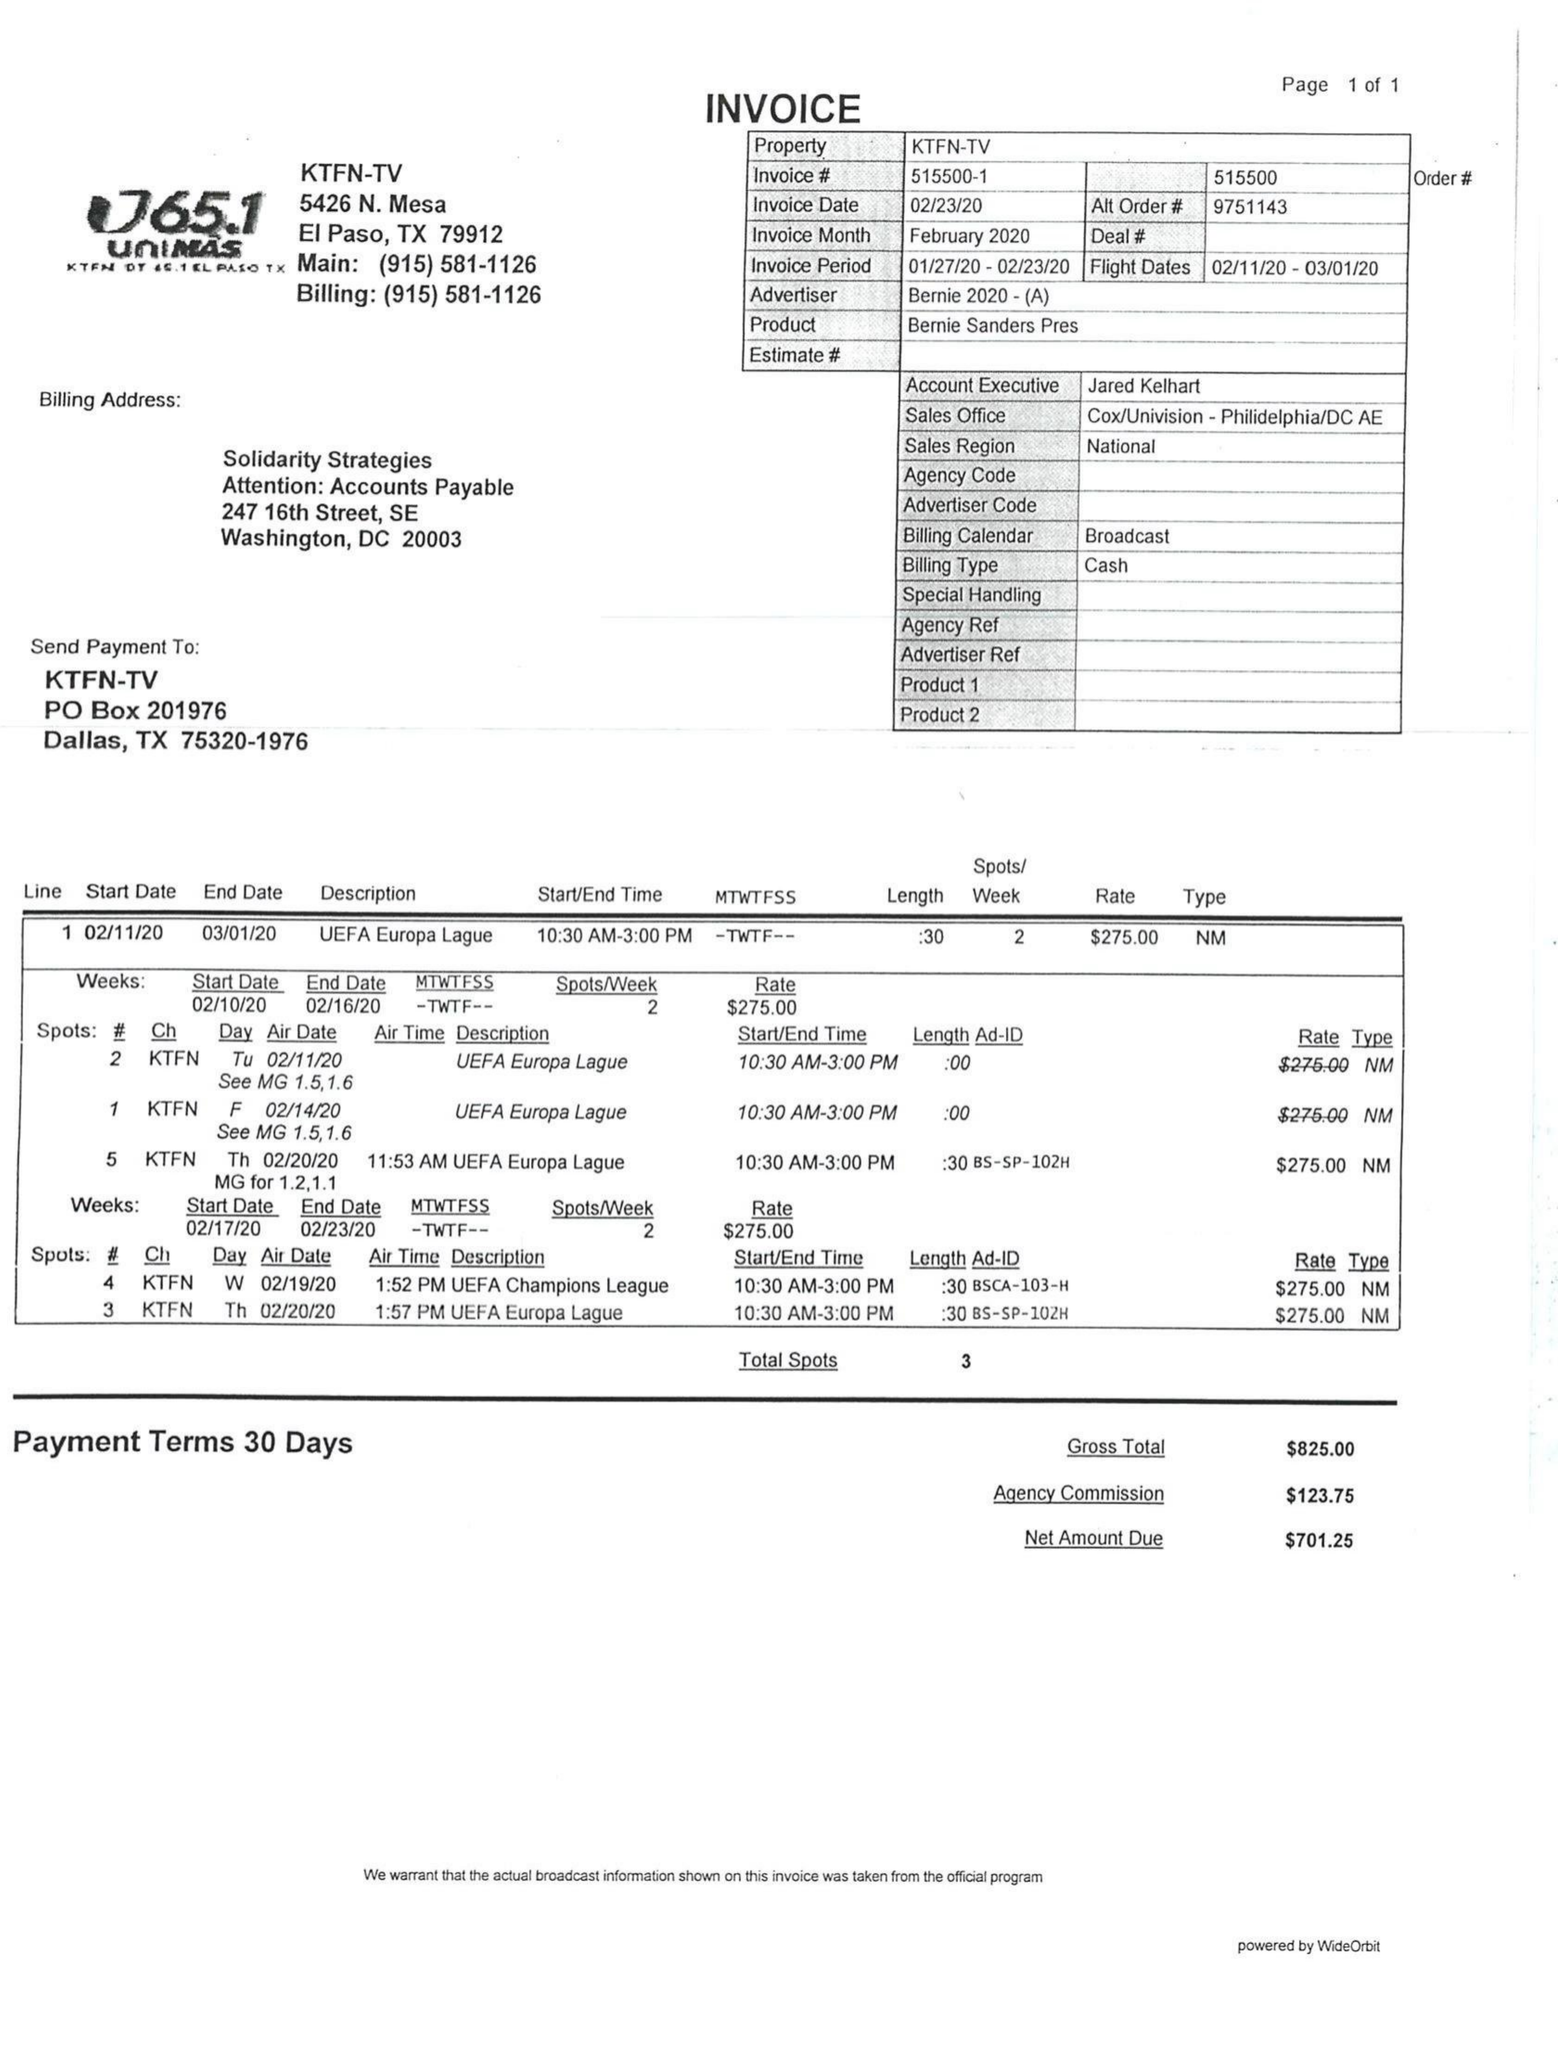What is the value for the flight_from?
Answer the question using a single word or phrase. 02/11/20 